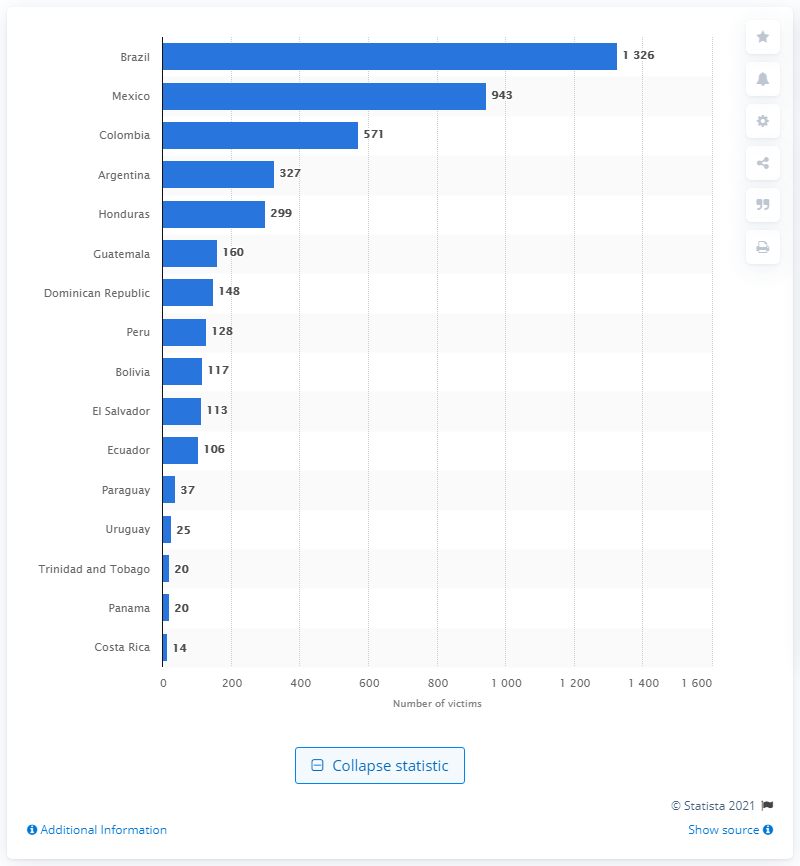Indicate a few pertinent items in this graphic. In 2019, a total of 943 women were killed in Mexico due to their gender. 